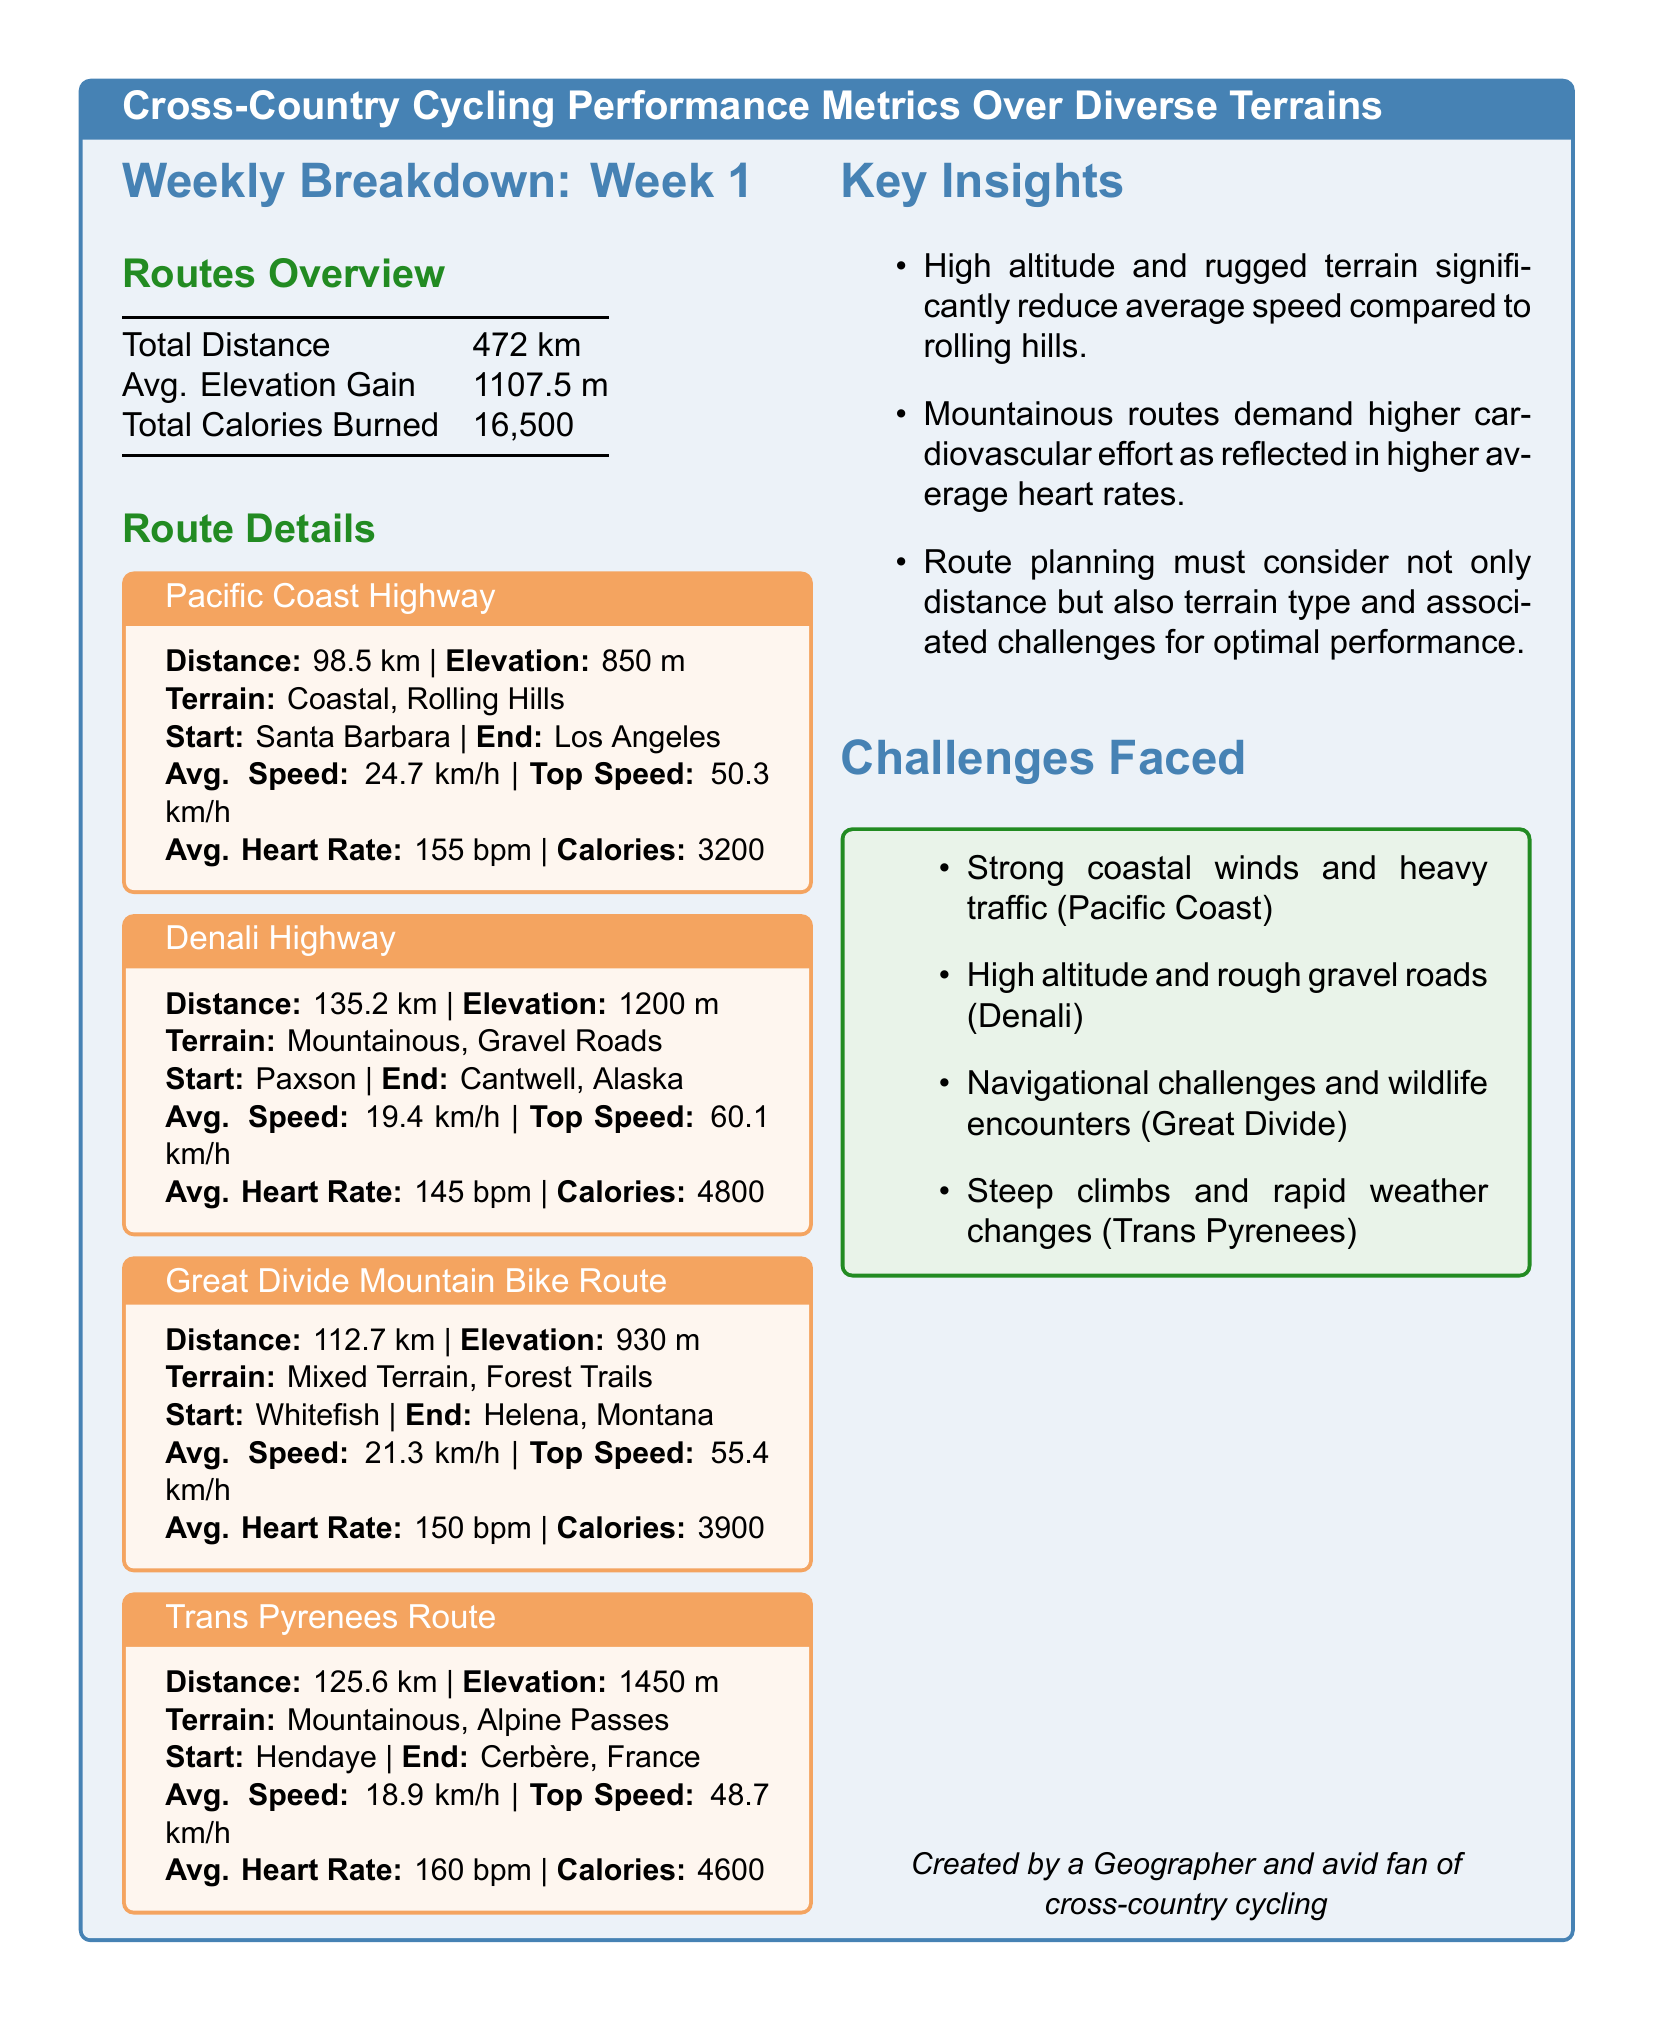what is the total distance cycled in week 1? The total distance is stated in the Routes Overview section of the document.
Answer: 472 km what is the elevation gain on the Trans Pyrenees Route? The elevation gain for the Trans Pyrenees Route is mentioned in its specific route details.
Answer: 1450 m what is the average speed on the Denali Highway? The average speed is provided under the Route Details for the Denali Highway.
Answer: 19.4 km/h how many calories were burned during the Great Divide Mountain Bike Route? The total calories burned for the Great Divide Mountain Bike Route are listed in its specific details.
Answer: 3900 which route had the highest average heart rate? To determine this, we can compare the average heart rates mentioned in the route details of all routes.
Answer: Trans Pyrenees Route why does the document suggest that mountainous routes require higher cardiovascular effort? This is inferred from the average heart rates and elevation gains associated with the routes.
Answer: Higher heart rates what was one challenge faced on the Pacific Coast Highway? The challenges faced are listed in the Challenges Faced section of the document.
Answer: Strong coastal winds which terrain type corresponds to the Great Divide Mountain Bike Route? The terrain type is specified in the Route Details of the Great Divide section.
Answer: Mixed Terrain, Forest Trails how many km is the Pacific Coast Highway? The distance for the Pacific Coast Highway is explicitly mentioned in its route details.
Answer: 98.5 km 